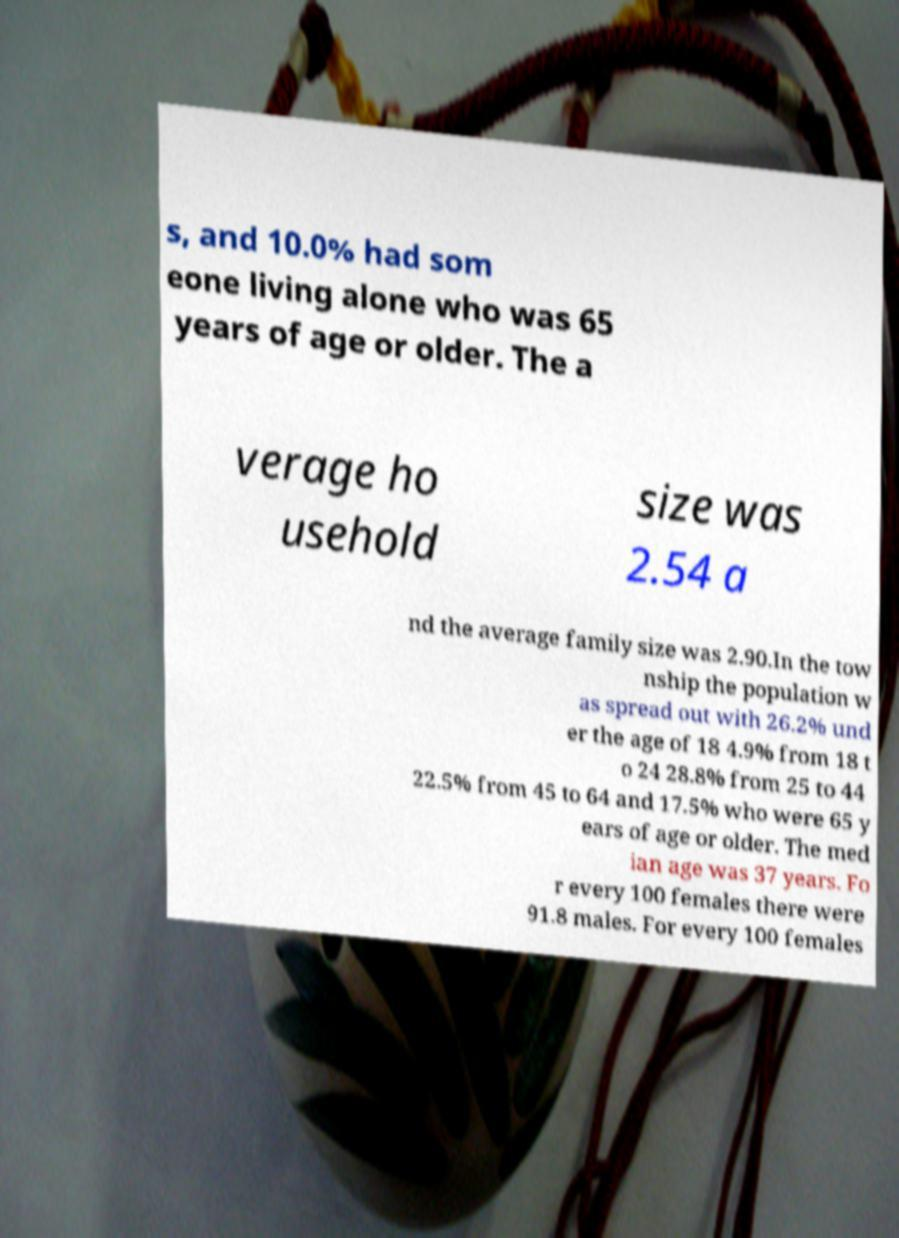Please read and relay the text visible in this image. What does it say? s, and 10.0% had som eone living alone who was 65 years of age or older. The a verage ho usehold size was 2.54 a nd the average family size was 2.90.In the tow nship the population w as spread out with 26.2% und er the age of 18 4.9% from 18 t o 24 28.8% from 25 to 44 22.5% from 45 to 64 and 17.5% who were 65 y ears of age or older. The med ian age was 37 years. Fo r every 100 females there were 91.8 males. For every 100 females 